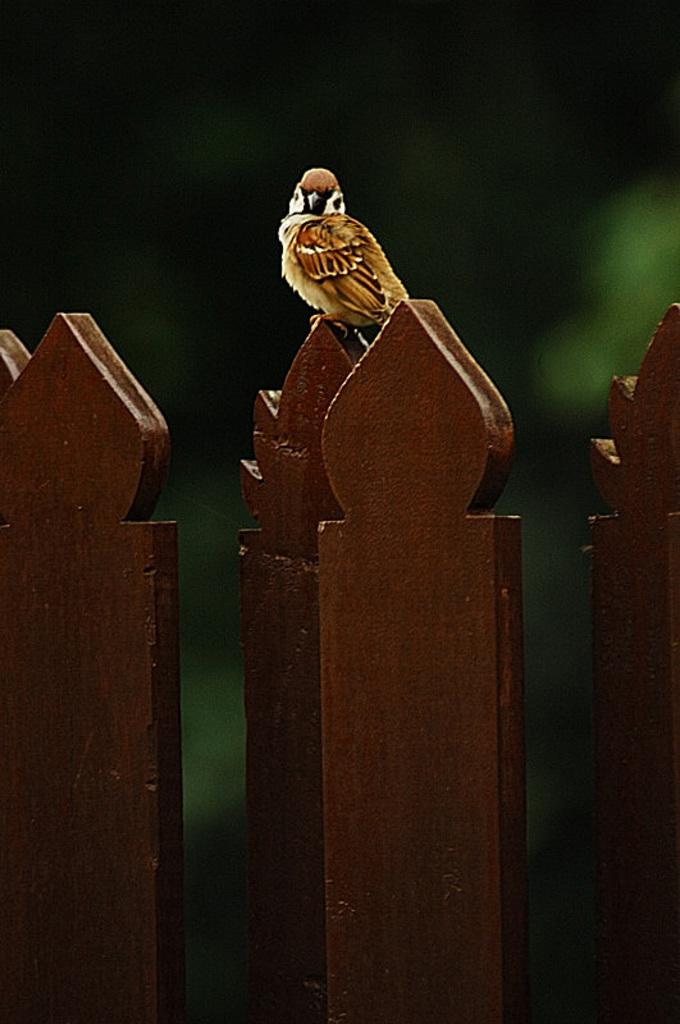What type of bird is in the image? There is a small sparrow in the image. Where is the sparrow located? The sparrow is sitting on a brown colored fence. What color is the background of the image? The background of the image is green. What medical advice does the doctor give to the sparrow in the image? There is no doctor present in the image, and the sparrow does not receive any medical advice. 